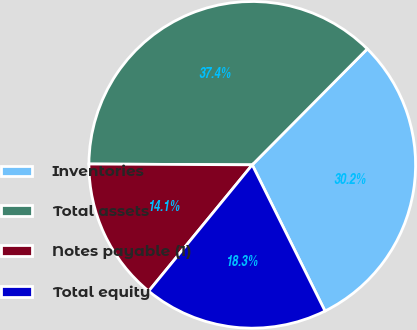<chart> <loc_0><loc_0><loc_500><loc_500><pie_chart><fcel>Inventories<fcel>Total assets<fcel>Notes payable (1)<fcel>Total equity<nl><fcel>30.21%<fcel>37.36%<fcel>14.15%<fcel>18.28%<nl></chart> 